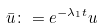<formula> <loc_0><loc_0><loc_500><loc_500>\bar { u } \colon = e ^ { - \lambda _ { 1 } t } u</formula> 